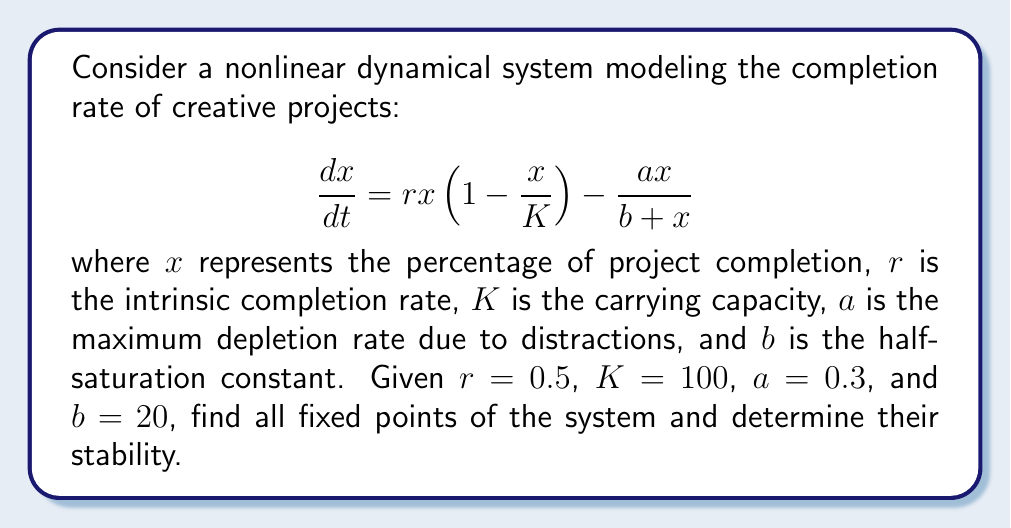Show me your answer to this math problem. 1. To find the fixed points, set $\frac{dx}{dt} = 0$:

   $$0 = rx(1-\frac{x}{K}) - \frac{ax}{b+x}$$

2. Substitute the given values:

   $$0 = 0.5x(1-\frac{x}{100}) - \frac{0.3x}{20+x}$$

3. Multiply both sides by $(20+x)$:

   $$0 = 0.5x(1-\frac{x}{100})(20+x) - 0.3x$$

4. Expand and simplify:

   $$0 = 10x + 0.5x^2 - 0.1x^2 - 0.005x^3 - 0.3x$$

   $$0 = 9.7x + 0.4x^2 - 0.005x^3$$

   $$0 = x(9.7 + 0.4x - 0.005x^2)$$

5. Solve for $x$:
   - $x = 0$ is one fixed point
   - For the quadratic part: $9.7 + 0.4x - 0.005x^2 = 0$
   
   Use the quadratic formula: $x = \frac{-b \pm \sqrt{b^2 - 4ac}}{2a}$
   
   $$x = \frac{-0.4 \pm \sqrt{0.4^2 - 4(9.7)(-0.005)}}{2(-0.005)}$$
   
   $$x \approx 80.4 \text{ or } x \approx 242.9$$

6. The fixed point $x \approx 242.9$ is not biologically relevant as it exceeds 100%, so we discard it.

7. To determine stability, evaluate $\frac{d}{dx}(\frac{dx}{dt})$ at each fixed point:

   $$\frac{d}{dx}(\frac{dx}{dt}) = r(1-\frac{2x}{K}) - \frac{ab}{(b+x)^2}$$

8. Substitute the values:

   $$\frac{d}{dx}(\frac{dx}{dt}) = 0.5(1-\frac{2x}{100}) - \frac{6}{(20+x)^2}$$

9. Evaluate at $x = 0$:

   $$\left.\frac{d}{dx}(\frac{dx}{dt})\right|_{x=0} = 0.5 - \frac{6}{400} = 0.485 > 0$$

   Therefore, $x = 0$ is unstable.

10. Evaluate at $x = 80.4$:

    $$\left.\frac{d}{dx}(\frac{dx}{dt})\right|_{x=80.4} \approx -0.304 < 0$$

    Therefore, $x = 80.4$ is stable.
Answer: Two fixed points: $x_1 = 0$ (unstable), $x_2 \approx 80.4$ (stable) 